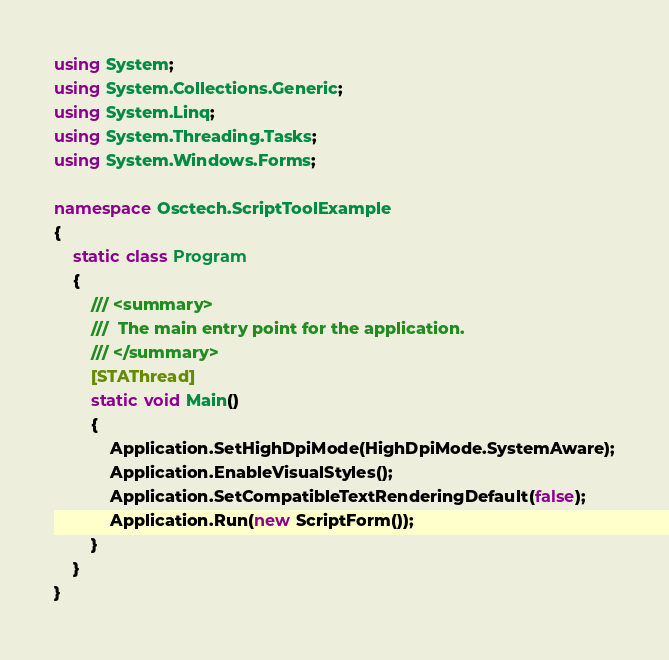<code> <loc_0><loc_0><loc_500><loc_500><_C#_>using System;
using System.Collections.Generic;
using System.Linq;
using System.Threading.Tasks;
using System.Windows.Forms;

namespace Osctech.ScriptToolExample
{
    static class Program
    {
        /// <summary>
        ///  The main entry point for the application.
        /// </summary>
        [STAThread]
        static void Main()
        {
            Application.SetHighDpiMode(HighDpiMode.SystemAware);
            Application.EnableVisualStyles();
            Application.SetCompatibleTextRenderingDefault(false);
            Application.Run(new ScriptForm());
        }
    }
}
</code> 